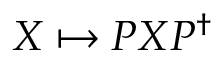Convert formula to latex. <formula><loc_0><loc_0><loc_500><loc_500>X \mapsto P X P ^ { \dagger }</formula> 